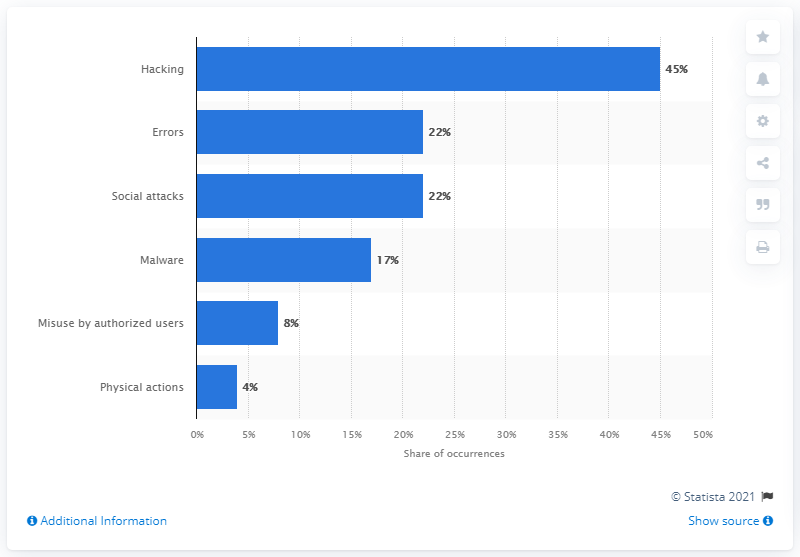Outline some significant characteristics in this image. In 2019, errors were the second most common cause of data breaches. 